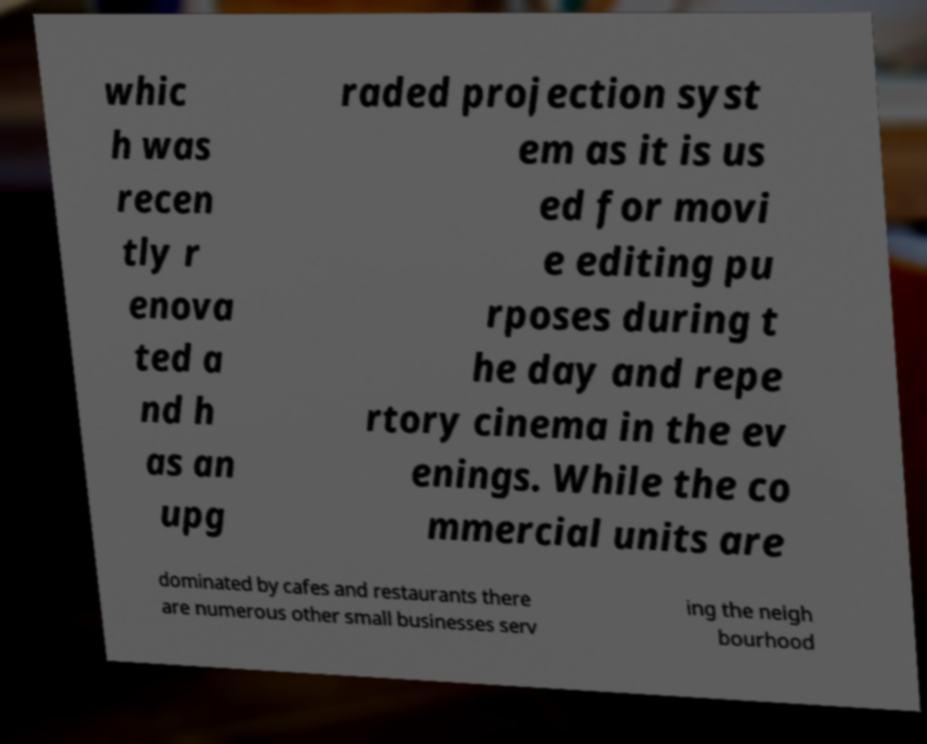I need the written content from this picture converted into text. Can you do that? whic h was recen tly r enova ted a nd h as an upg raded projection syst em as it is us ed for movi e editing pu rposes during t he day and repe rtory cinema in the ev enings. While the co mmercial units are dominated by cafes and restaurants there are numerous other small businesses serv ing the neigh bourhood 